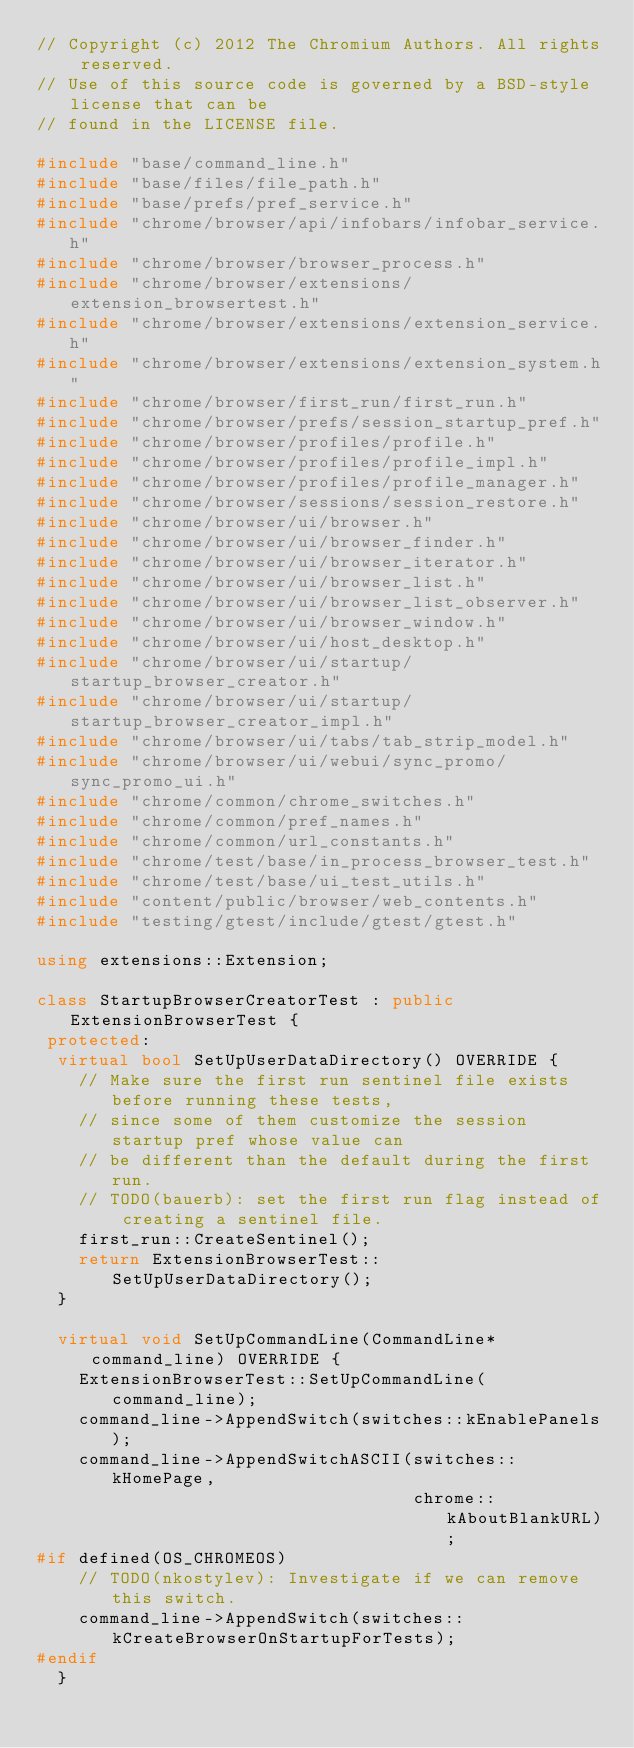Convert code to text. <code><loc_0><loc_0><loc_500><loc_500><_C++_>// Copyright (c) 2012 The Chromium Authors. All rights reserved.
// Use of this source code is governed by a BSD-style license that can be
// found in the LICENSE file.

#include "base/command_line.h"
#include "base/files/file_path.h"
#include "base/prefs/pref_service.h"
#include "chrome/browser/api/infobars/infobar_service.h"
#include "chrome/browser/browser_process.h"
#include "chrome/browser/extensions/extension_browsertest.h"
#include "chrome/browser/extensions/extension_service.h"
#include "chrome/browser/extensions/extension_system.h"
#include "chrome/browser/first_run/first_run.h"
#include "chrome/browser/prefs/session_startup_pref.h"
#include "chrome/browser/profiles/profile.h"
#include "chrome/browser/profiles/profile_impl.h"
#include "chrome/browser/profiles/profile_manager.h"
#include "chrome/browser/sessions/session_restore.h"
#include "chrome/browser/ui/browser.h"
#include "chrome/browser/ui/browser_finder.h"
#include "chrome/browser/ui/browser_iterator.h"
#include "chrome/browser/ui/browser_list.h"
#include "chrome/browser/ui/browser_list_observer.h"
#include "chrome/browser/ui/browser_window.h"
#include "chrome/browser/ui/host_desktop.h"
#include "chrome/browser/ui/startup/startup_browser_creator.h"
#include "chrome/browser/ui/startup/startup_browser_creator_impl.h"
#include "chrome/browser/ui/tabs/tab_strip_model.h"
#include "chrome/browser/ui/webui/sync_promo/sync_promo_ui.h"
#include "chrome/common/chrome_switches.h"
#include "chrome/common/pref_names.h"
#include "chrome/common/url_constants.h"
#include "chrome/test/base/in_process_browser_test.h"
#include "chrome/test/base/ui_test_utils.h"
#include "content/public/browser/web_contents.h"
#include "testing/gtest/include/gtest/gtest.h"

using extensions::Extension;

class StartupBrowserCreatorTest : public ExtensionBrowserTest {
 protected:
  virtual bool SetUpUserDataDirectory() OVERRIDE {
    // Make sure the first run sentinel file exists before running these tests,
    // since some of them customize the session startup pref whose value can
    // be different than the default during the first run.
    // TODO(bauerb): set the first run flag instead of creating a sentinel file.
    first_run::CreateSentinel();
    return ExtensionBrowserTest::SetUpUserDataDirectory();
  }

  virtual void SetUpCommandLine(CommandLine* command_line) OVERRIDE {
    ExtensionBrowserTest::SetUpCommandLine(command_line);
    command_line->AppendSwitch(switches::kEnablePanels);
    command_line->AppendSwitchASCII(switches::kHomePage,
                                    chrome::kAboutBlankURL);
#if defined(OS_CHROMEOS)
    // TODO(nkostylev): Investigate if we can remove this switch.
    command_line->AppendSwitch(switches::kCreateBrowserOnStartupForTests);
#endif
  }
</code> 